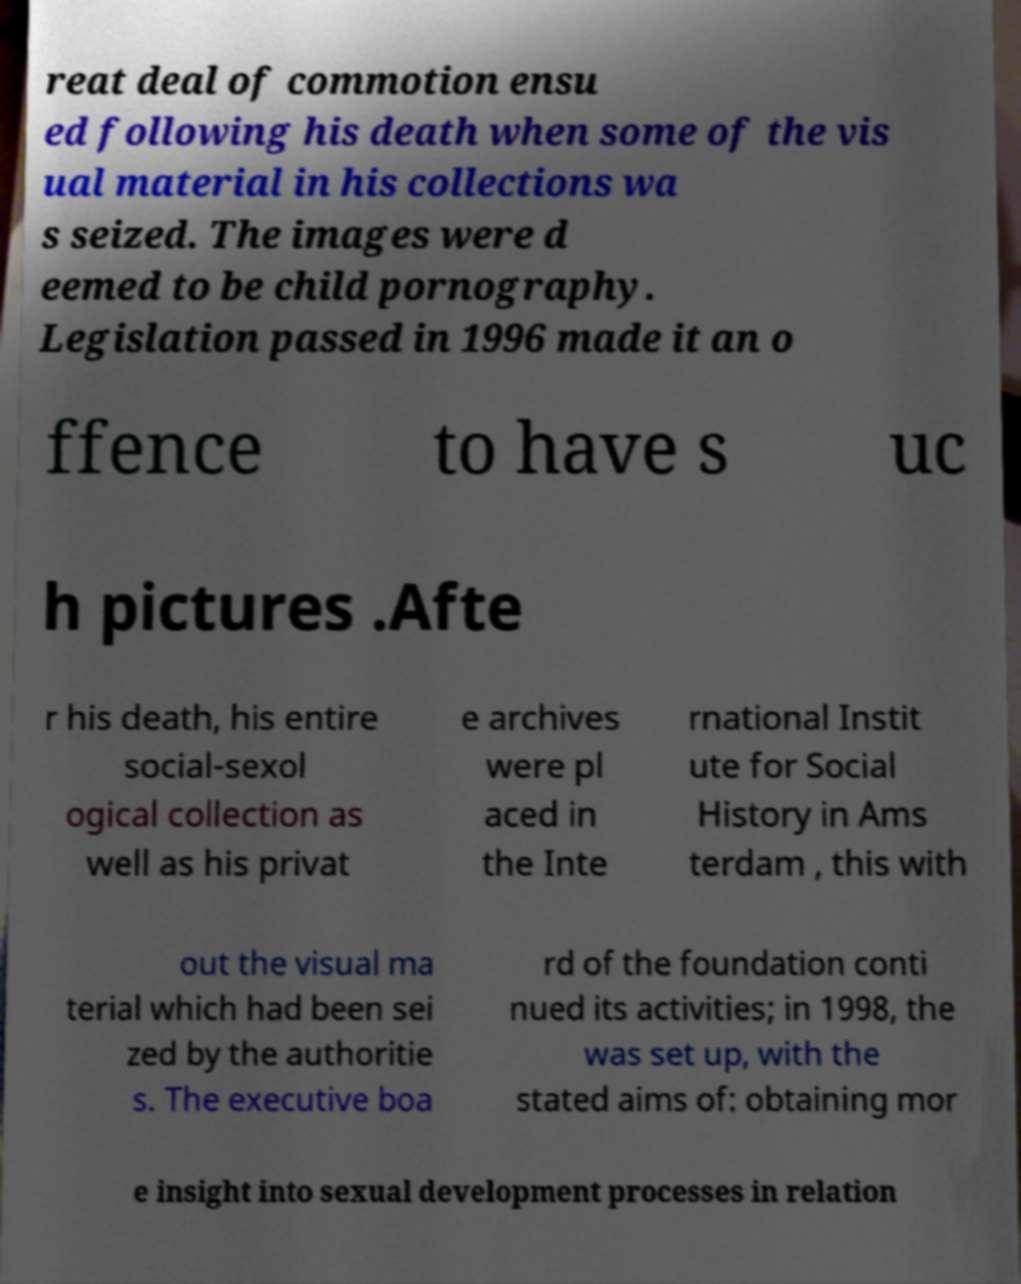There's text embedded in this image that I need extracted. Can you transcribe it verbatim? reat deal of commotion ensu ed following his death when some of the vis ual material in his collections wa s seized. The images were d eemed to be child pornography. Legislation passed in 1996 made it an o ffence to have s uc h pictures .Afte r his death, his entire social-sexol ogical collection as well as his privat e archives were pl aced in the Inte rnational Instit ute for Social History in Ams terdam , this with out the visual ma terial which had been sei zed by the authoritie s. The executive boa rd of the foundation conti nued its activities; in 1998, the was set up, with the stated aims of: obtaining mor e insight into sexual development processes in relation 